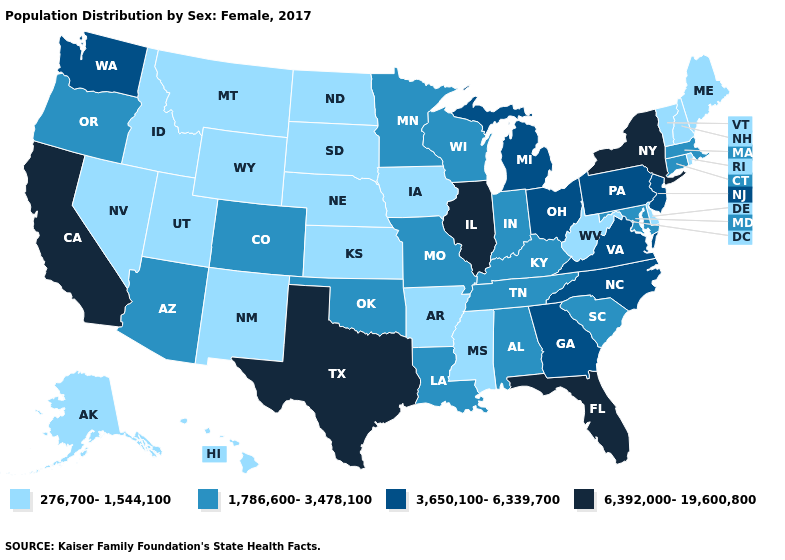Which states have the lowest value in the West?
Concise answer only. Alaska, Hawaii, Idaho, Montana, Nevada, New Mexico, Utah, Wyoming. Among the states that border Louisiana , which have the lowest value?
Short answer required. Arkansas, Mississippi. What is the value of California?
Concise answer only. 6,392,000-19,600,800. What is the value of Louisiana?
Write a very short answer. 1,786,600-3,478,100. Which states have the lowest value in the USA?
Concise answer only. Alaska, Arkansas, Delaware, Hawaii, Idaho, Iowa, Kansas, Maine, Mississippi, Montana, Nebraska, Nevada, New Hampshire, New Mexico, North Dakota, Rhode Island, South Dakota, Utah, Vermont, West Virginia, Wyoming. Name the states that have a value in the range 6,392,000-19,600,800?
Concise answer only. California, Florida, Illinois, New York, Texas. Name the states that have a value in the range 276,700-1,544,100?
Concise answer only. Alaska, Arkansas, Delaware, Hawaii, Idaho, Iowa, Kansas, Maine, Mississippi, Montana, Nebraska, Nevada, New Hampshire, New Mexico, North Dakota, Rhode Island, South Dakota, Utah, Vermont, West Virginia, Wyoming. What is the highest value in the West ?
Keep it brief. 6,392,000-19,600,800. Does Idaho have the same value as Arizona?
Short answer required. No. Among the states that border Arizona , does California have the lowest value?
Quick response, please. No. Does South Dakota have the highest value in the MidWest?
Short answer required. No. Does Oklahoma have the same value as Pennsylvania?
Quick response, please. No. Among the states that border Kentucky , which have the lowest value?
Concise answer only. West Virginia. Does Kentucky have the highest value in the South?
Be succinct. No. 